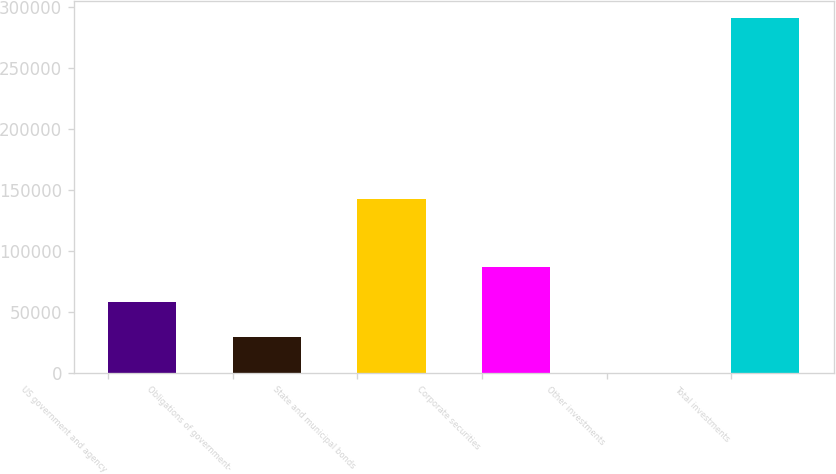<chart> <loc_0><loc_0><loc_500><loc_500><bar_chart><fcel>US government and agency<fcel>Obligations of government-<fcel>State and municipal bonds<fcel>Corporate securities<fcel>Other investments<fcel>Total investments<nl><fcel>58243.4<fcel>29139.7<fcel>142586<fcel>87347.1<fcel>36<fcel>291073<nl></chart> 